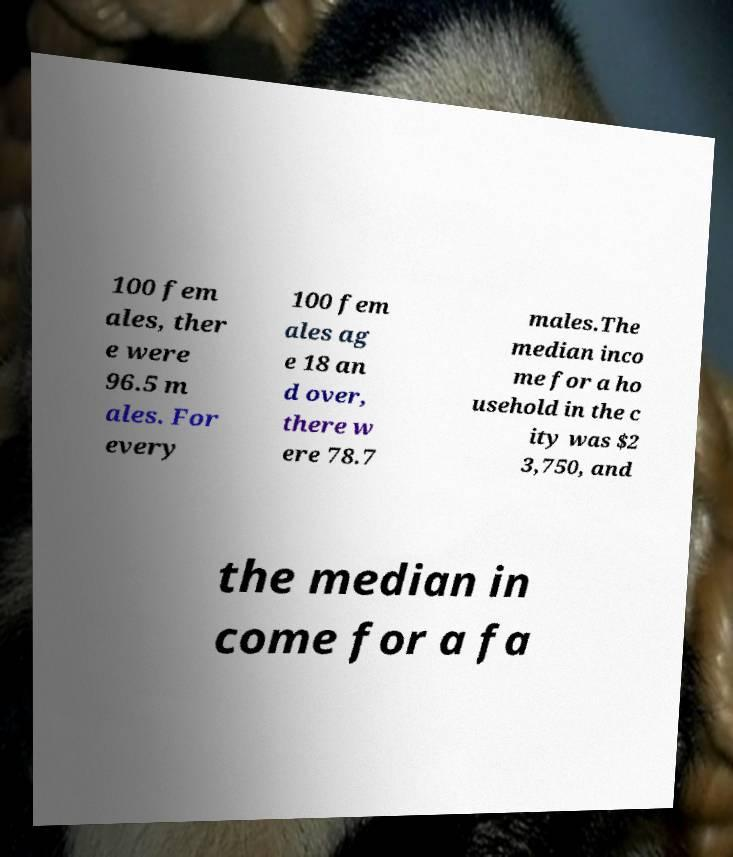Could you assist in decoding the text presented in this image and type it out clearly? 100 fem ales, ther e were 96.5 m ales. For every 100 fem ales ag e 18 an d over, there w ere 78.7 males.The median inco me for a ho usehold in the c ity was $2 3,750, and the median in come for a fa 